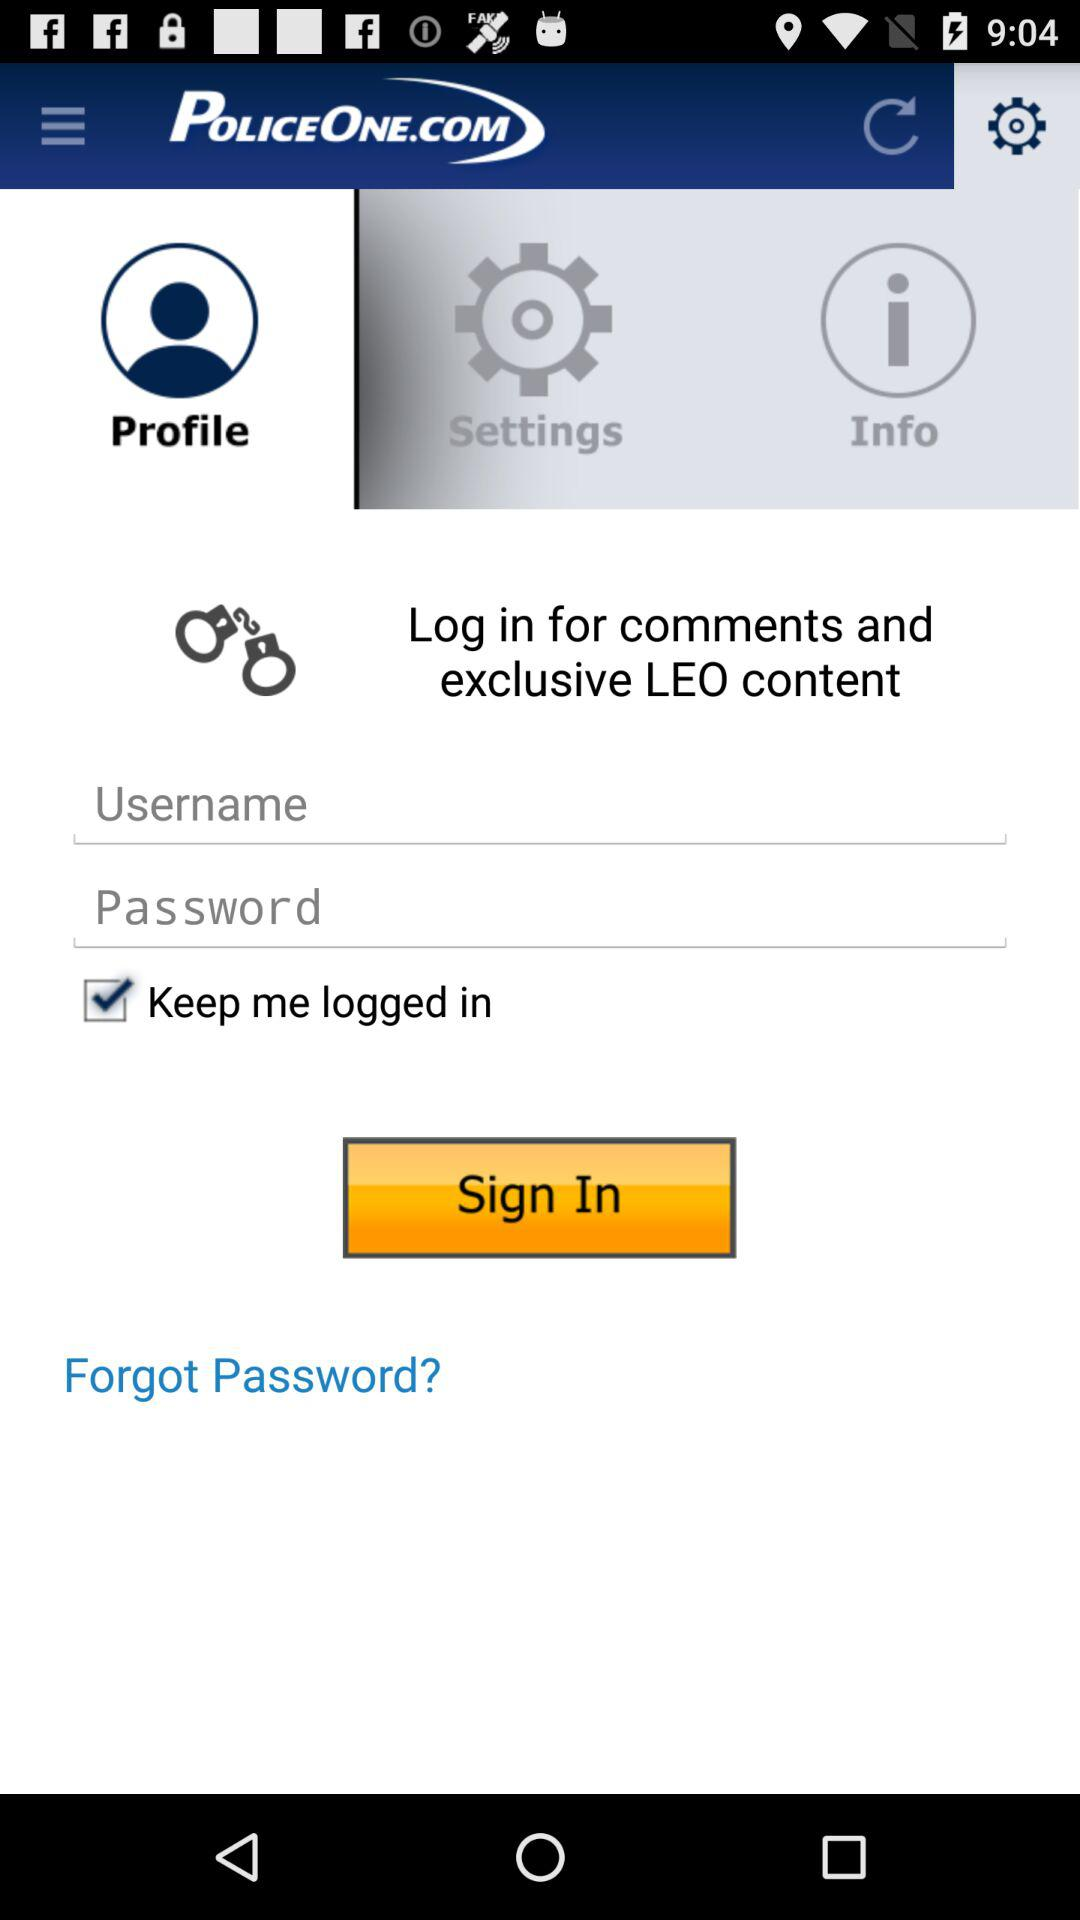How many text input fields are there in the log in screen?
Answer the question using a single word or phrase. 2 